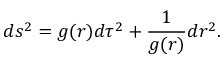Convert formula to latex. <formula><loc_0><loc_0><loc_500><loc_500>d s ^ { 2 } = g ( r ) d \tau ^ { 2 } + { \frac { 1 } { g ( r ) } } d r ^ { 2 } .</formula> 